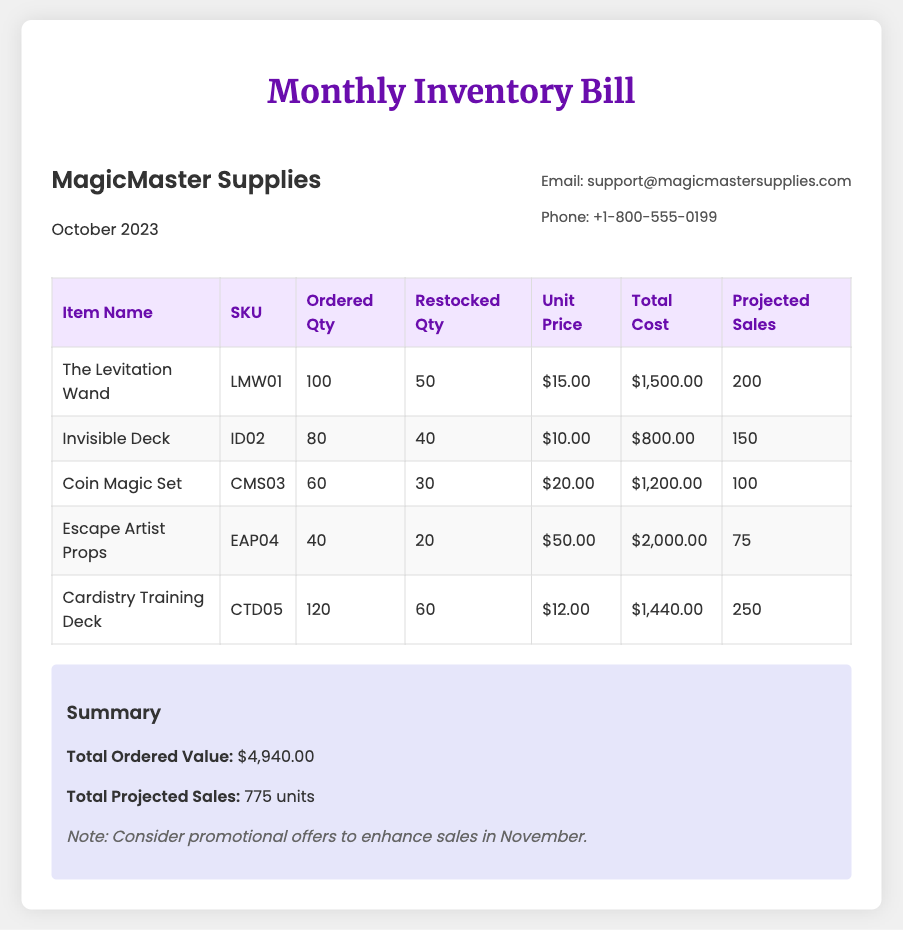What is the total ordered value? The total ordered value is found in the summary section of the document.
Answer: $4,940.00 How many units of "The Levitation Wand" are projected for sales? The projected sales for "The Levitation Wand" can be found in the relevant row of the table.
Answer: 200 What is the unit price of the "Invisible Deck"? The unit price is listed alongside the item details in the table.
Answer: $10.00 How many items were restocked for the "Cardistry Training Deck"? The restocked quantity is shown in the table for each item.
Answer: 60 Which item has the highest projected sales? The item with the highest projected sales can be determined by comparing sales figures in the last column of the table.
Answer: Cardistry Training Deck What is the SKU for the "Escape Artist Props"? The SKU is provided in the respective row of the inventory table.
Answer: EAP04 How many items were ordered for the "Coin Magic Set"? The ordered quantity is indicated in the table under the corresponding column for that item.
Answer: 60 What is the total projected sales across all items? The total projected sales is summarized in the relevant section of the bill.
Answer: 775 units 